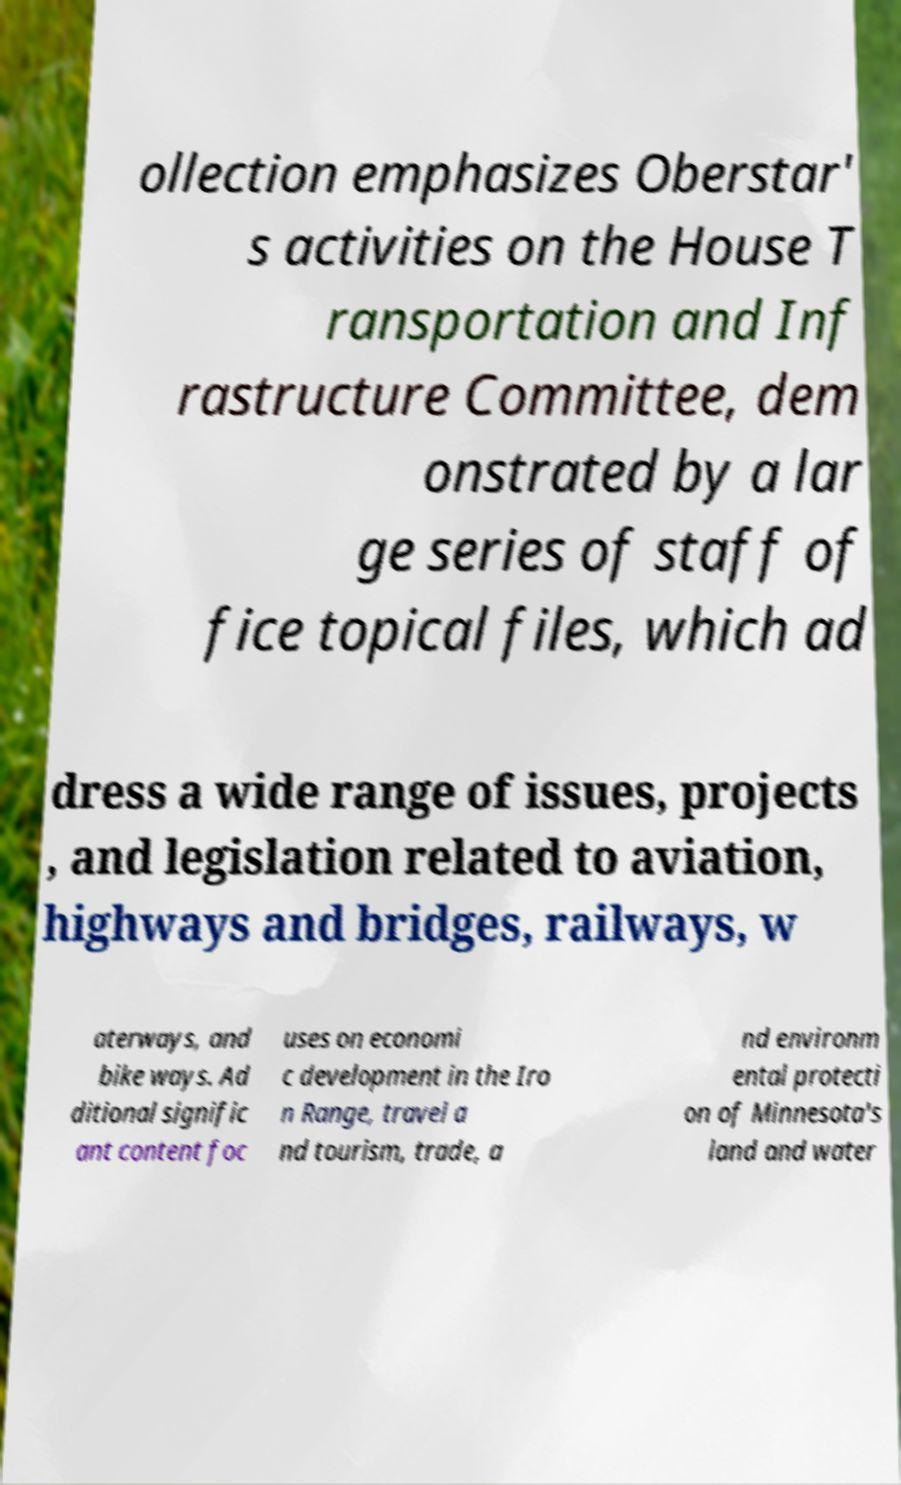I need the written content from this picture converted into text. Can you do that? ollection emphasizes Oberstar' s activities on the House T ransportation and Inf rastructure Committee, dem onstrated by a lar ge series of staff of fice topical files, which ad dress a wide range of issues, projects , and legislation related to aviation, highways and bridges, railways, w aterways, and bike ways. Ad ditional signific ant content foc uses on economi c development in the Iro n Range, travel a nd tourism, trade, a nd environm ental protecti on of Minnesota's land and water 